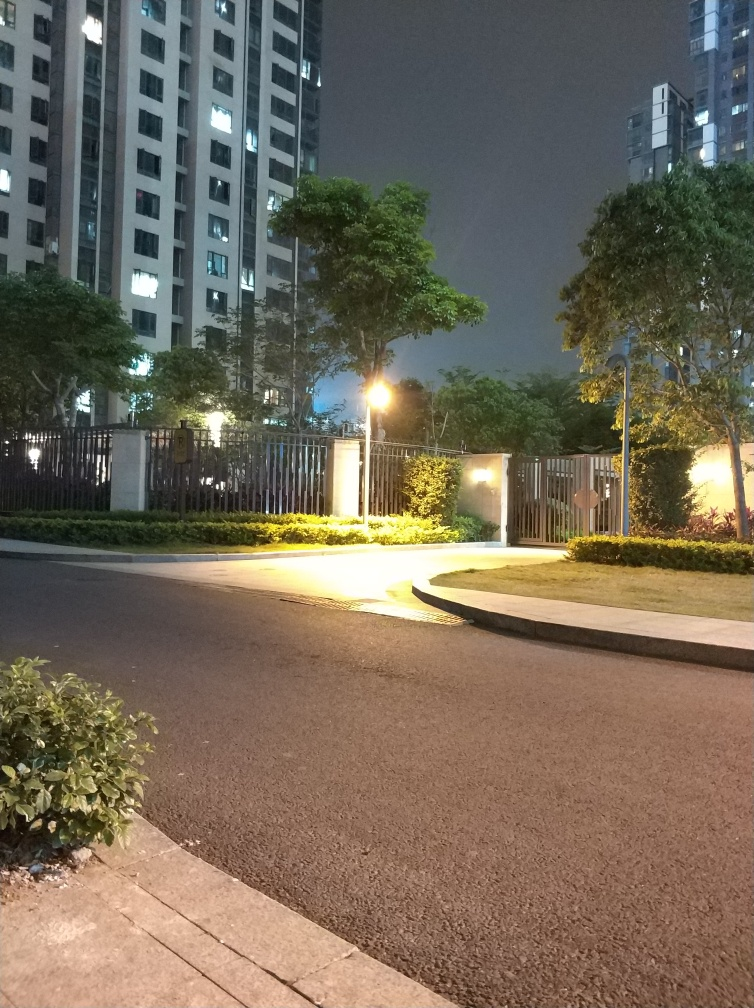Is the location shown in the photo likely to be quiet or noisy at the time the photo was taken? Judging by the absence of people and vehicles, the neatly trimmed hedges, and the calmness suggested by the lighting, it is likely a serene setting with minimal noise during the time this photo was taken. 